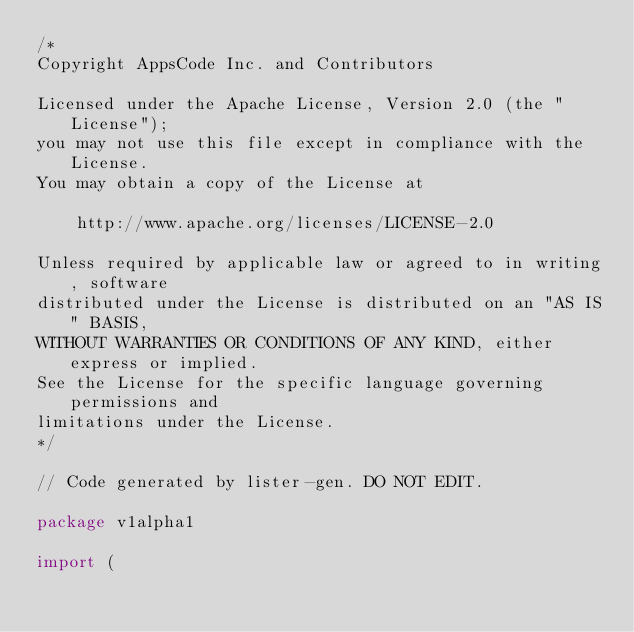<code> <loc_0><loc_0><loc_500><loc_500><_Go_>/*
Copyright AppsCode Inc. and Contributors

Licensed under the Apache License, Version 2.0 (the "License");
you may not use this file except in compliance with the License.
You may obtain a copy of the License at

    http://www.apache.org/licenses/LICENSE-2.0

Unless required by applicable law or agreed to in writing, software
distributed under the License is distributed on an "AS IS" BASIS,
WITHOUT WARRANTIES OR CONDITIONS OF ANY KIND, either express or implied.
See the License for the specific language governing permissions and
limitations under the License.
*/

// Code generated by lister-gen. DO NOT EDIT.

package v1alpha1

import (</code> 